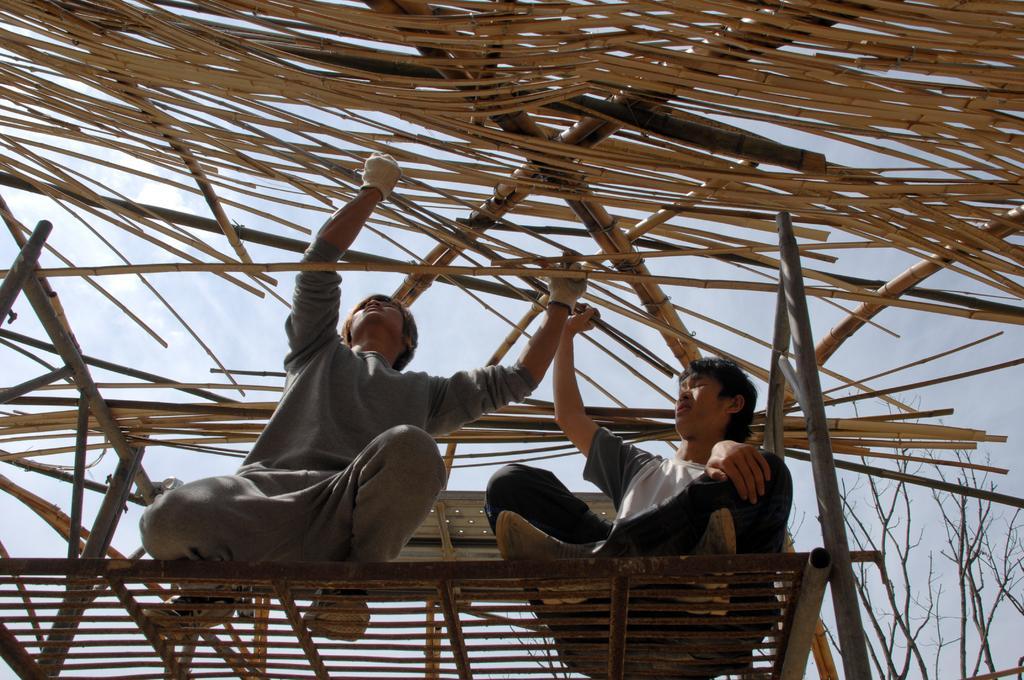Describe this image in one or two sentences. At the bottom of this image, there are two persons on a platform adjusting sticks which are above them. In the background, there are trees and there are clouds in the sky. 